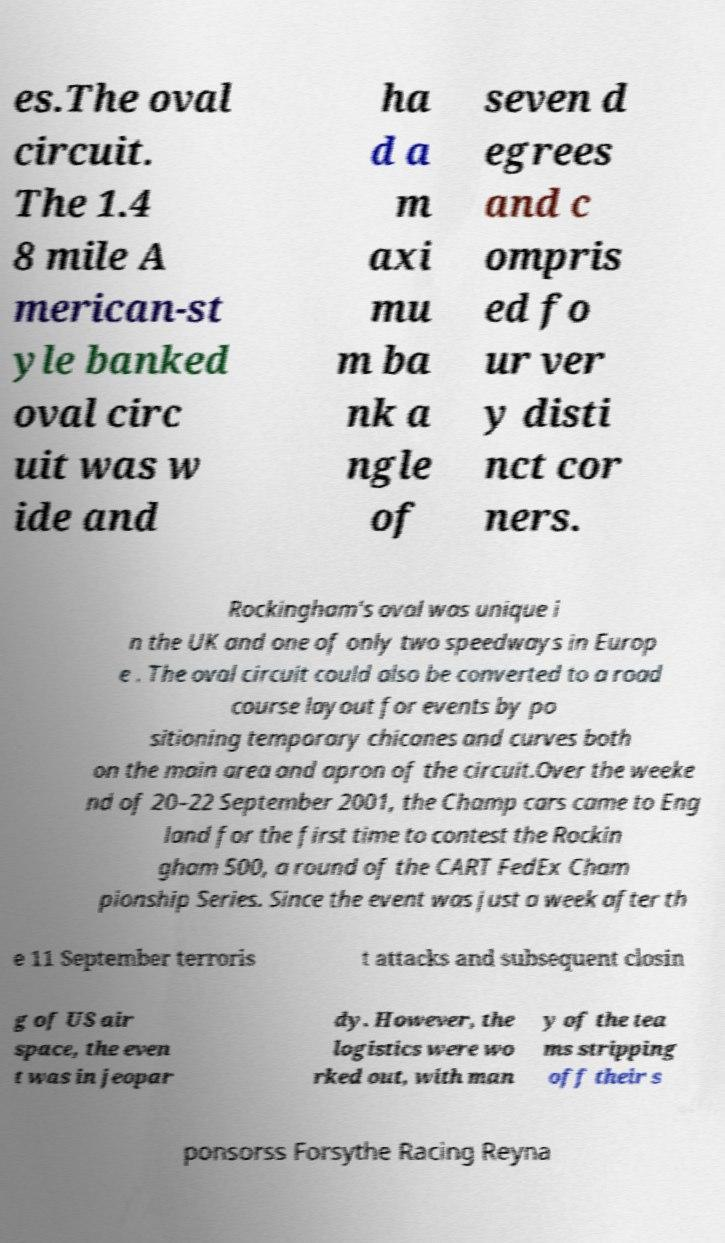For documentation purposes, I need the text within this image transcribed. Could you provide that? es.The oval circuit. The 1.4 8 mile A merican-st yle banked oval circ uit was w ide and ha d a m axi mu m ba nk a ngle of seven d egrees and c ompris ed fo ur ver y disti nct cor ners. Rockingham's oval was unique i n the UK and one of only two speedways in Europ e . The oval circuit could also be converted to a road course layout for events by po sitioning temporary chicanes and curves both on the main area and apron of the circuit.Over the weeke nd of 20–22 September 2001, the Champ cars came to Eng land for the first time to contest the Rockin gham 500, a round of the CART FedEx Cham pionship Series. Since the event was just a week after th e 11 September terroris t attacks and subsequent closin g of US air space, the even t was in jeopar dy. However, the logistics were wo rked out, with man y of the tea ms stripping off their s ponsorss Forsythe Racing Reyna 